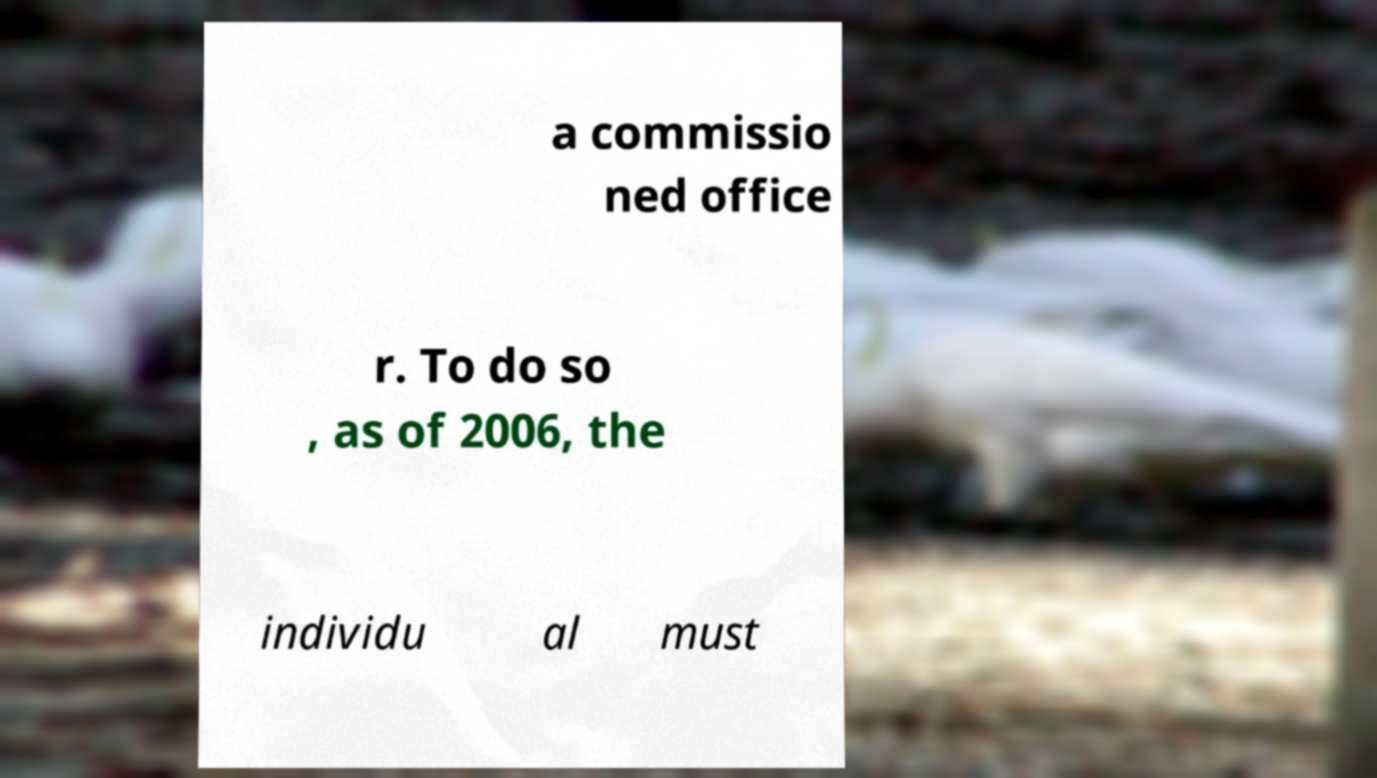Can you read and provide the text displayed in the image?This photo seems to have some interesting text. Can you extract and type it out for me? a commissio ned office r. To do so , as of 2006, the individu al must 